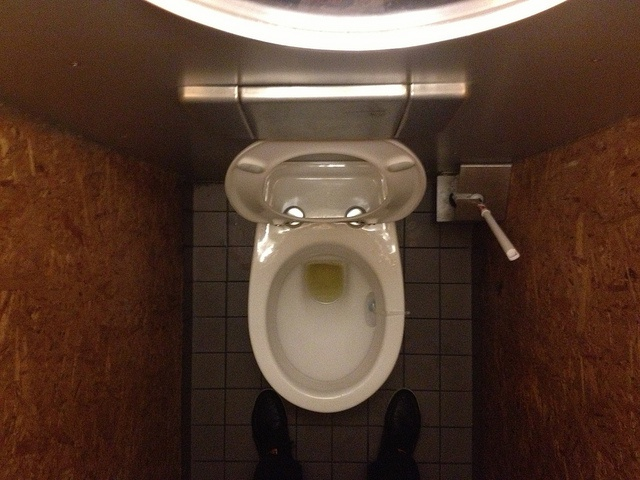Describe the objects in this image and their specific colors. I can see toilet in maroon, gray, and tan tones and people in black and maroon tones in this image. 